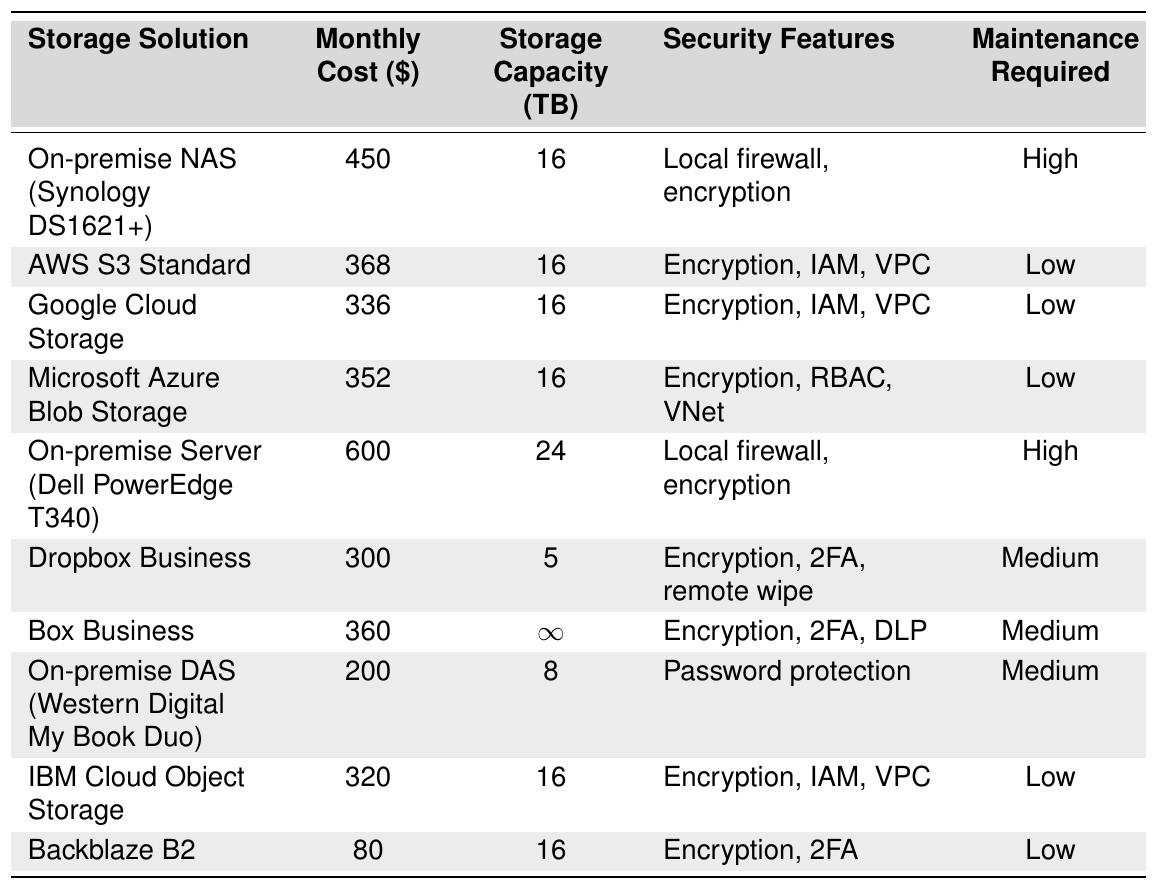What is the monthly cost of the On-premise NAS? The table lists the monthly cost of the On-premise NAS (Synology DS1621+) as $450.
Answer: 450 Which cloud storage solution has the lowest monthly cost? Looking through the table, Backblaze B2 has the lowest monthly cost at $80.
Answer: 80 How much more does the On-premise Server cost compared to Google Cloud Storage? The On-premise Server costs $600, while Google Cloud Storage costs $336. The difference is $600 - $336 = $264.
Answer: 264 Is Box Business the most expensive solution in the table? The most expensive solution is the On-premise Server at $600; Box Business costs $360, which is less than that.
Answer: No What is the total storage capacity of all listed cloud storage solutions? The table shows cloud storage solutions with capacities: AWS S3 (16), Google Cloud Storage (16), Microsoft Azure (16), IBM Cloud (16), and Backblaze (16). Summing these gives: 16 + 16 + 16 + 16 + 16 = 80 TB.
Answer: 80 TB Which storage solution offers the most capacity? The Box Business solution offers an infinite storage capacity as indicated in the table.
Answer: Infinity Do all cloud storage solutions require low maintenance? The table indicates low maintenance for AWS, Google Cloud, Microsoft Azure, IBM Cloud, and Backblaze, but Medium maintenance is required for Dropbox and Box. Hence, not all require low maintenance.
Answer: No What is the average monthly cost of the On-premise solutions listed? The On-premise solutions are: NAS ($450), Server ($600), and DAS ($200). The average is calculated as (450 + 600 + 200) / 3 = 450.
Answer: 450 Which storage option has encryption as a security feature and requires medium maintenance? Dropbox Business has encryption as a security feature and requires medium maintenance, as shown in the table.
Answer: Dropbox Business How many storage solutions have 2FA as a security feature? The table shows 2FA listed for Dropbox Business and Backblaze B2, totaling 2 solutions.
Answer: 2 